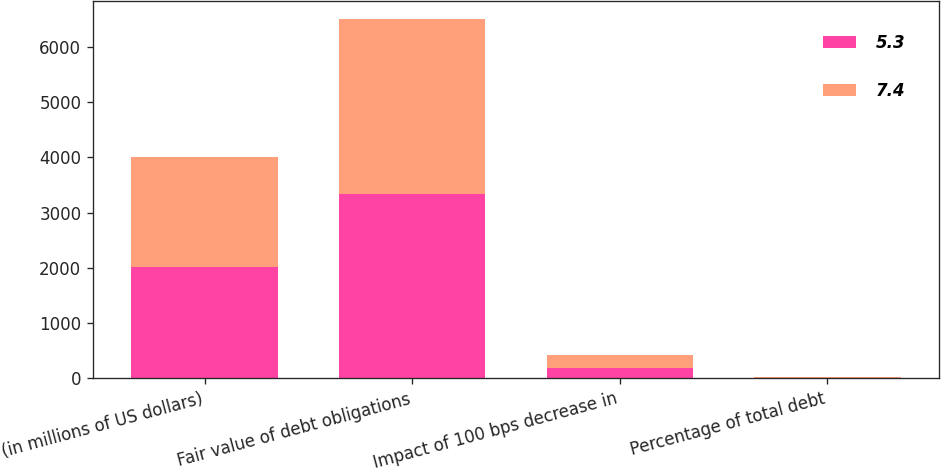<chart> <loc_0><loc_0><loc_500><loc_500><stacked_bar_chart><ecel><fcel>(in millions of US dollars)<fcel>Fair value of debt obligations<fcel>Impact of 100 bps decrease in<fcel>Percentage of total debt<nl><fcel>5.3<fcel>2008<fcel>3344<fcel>179<fcel>5.3<nl><fcel>7.4<fcel>2007<fcel>3169<fcel>235<fcel>7.4<nl></chart> 